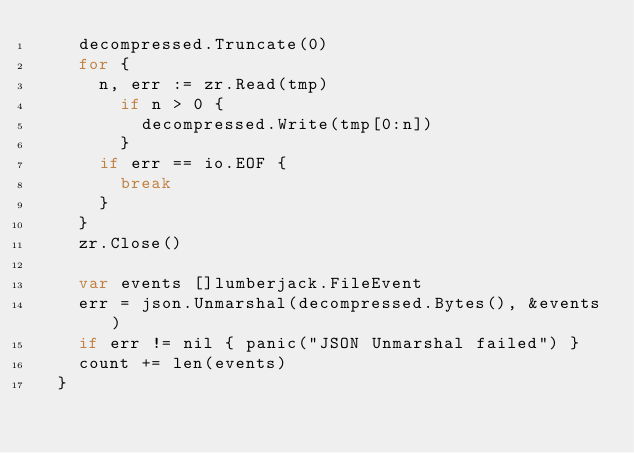Convert code to text. <code><loc_0><loc_0><loc_500><loc_500><_Go_>    decompressed.Truncate(0)
    for { 
      n, err := zr.Read(tmp)
        if n > 0 {
          decompressed.Write(tmp[0:n])
        }
      if err == io.EOF {
        break
      }
    }
    zr.Close()

    var events []lumberjack.FileEvent
    err = json.Unmarshal(decompressed.Bytes(), &events)
    if err != nil { panic("JSON Unmarshal failed") }
    count += len(events)
  }
</code> 